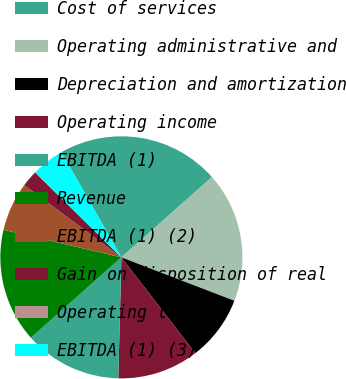<chart> <loc_0><loc_0><loc_500><loc_500><pie_chart><fcel>Cost of services<fcel>Operating administrative and<fcel>Depreciation and amortization<fcel>Operating income<fcel>EBITDA (1)<fcel>Revenue<fcel>EBITDA (1) (2)<fcel>Gain on disposition of real<fcel>Operating loss<fcel>EBITDA (1) (3)<nl><fcel>21.72%<fcel>17.38%<fcel>8.7%<fcel>10.87%<fcel>13.04%<fcel>15.21%<fcel>6.53%<fcel>2.19%<fcel>0.02%<fcel>4.36%<nl></chart> 